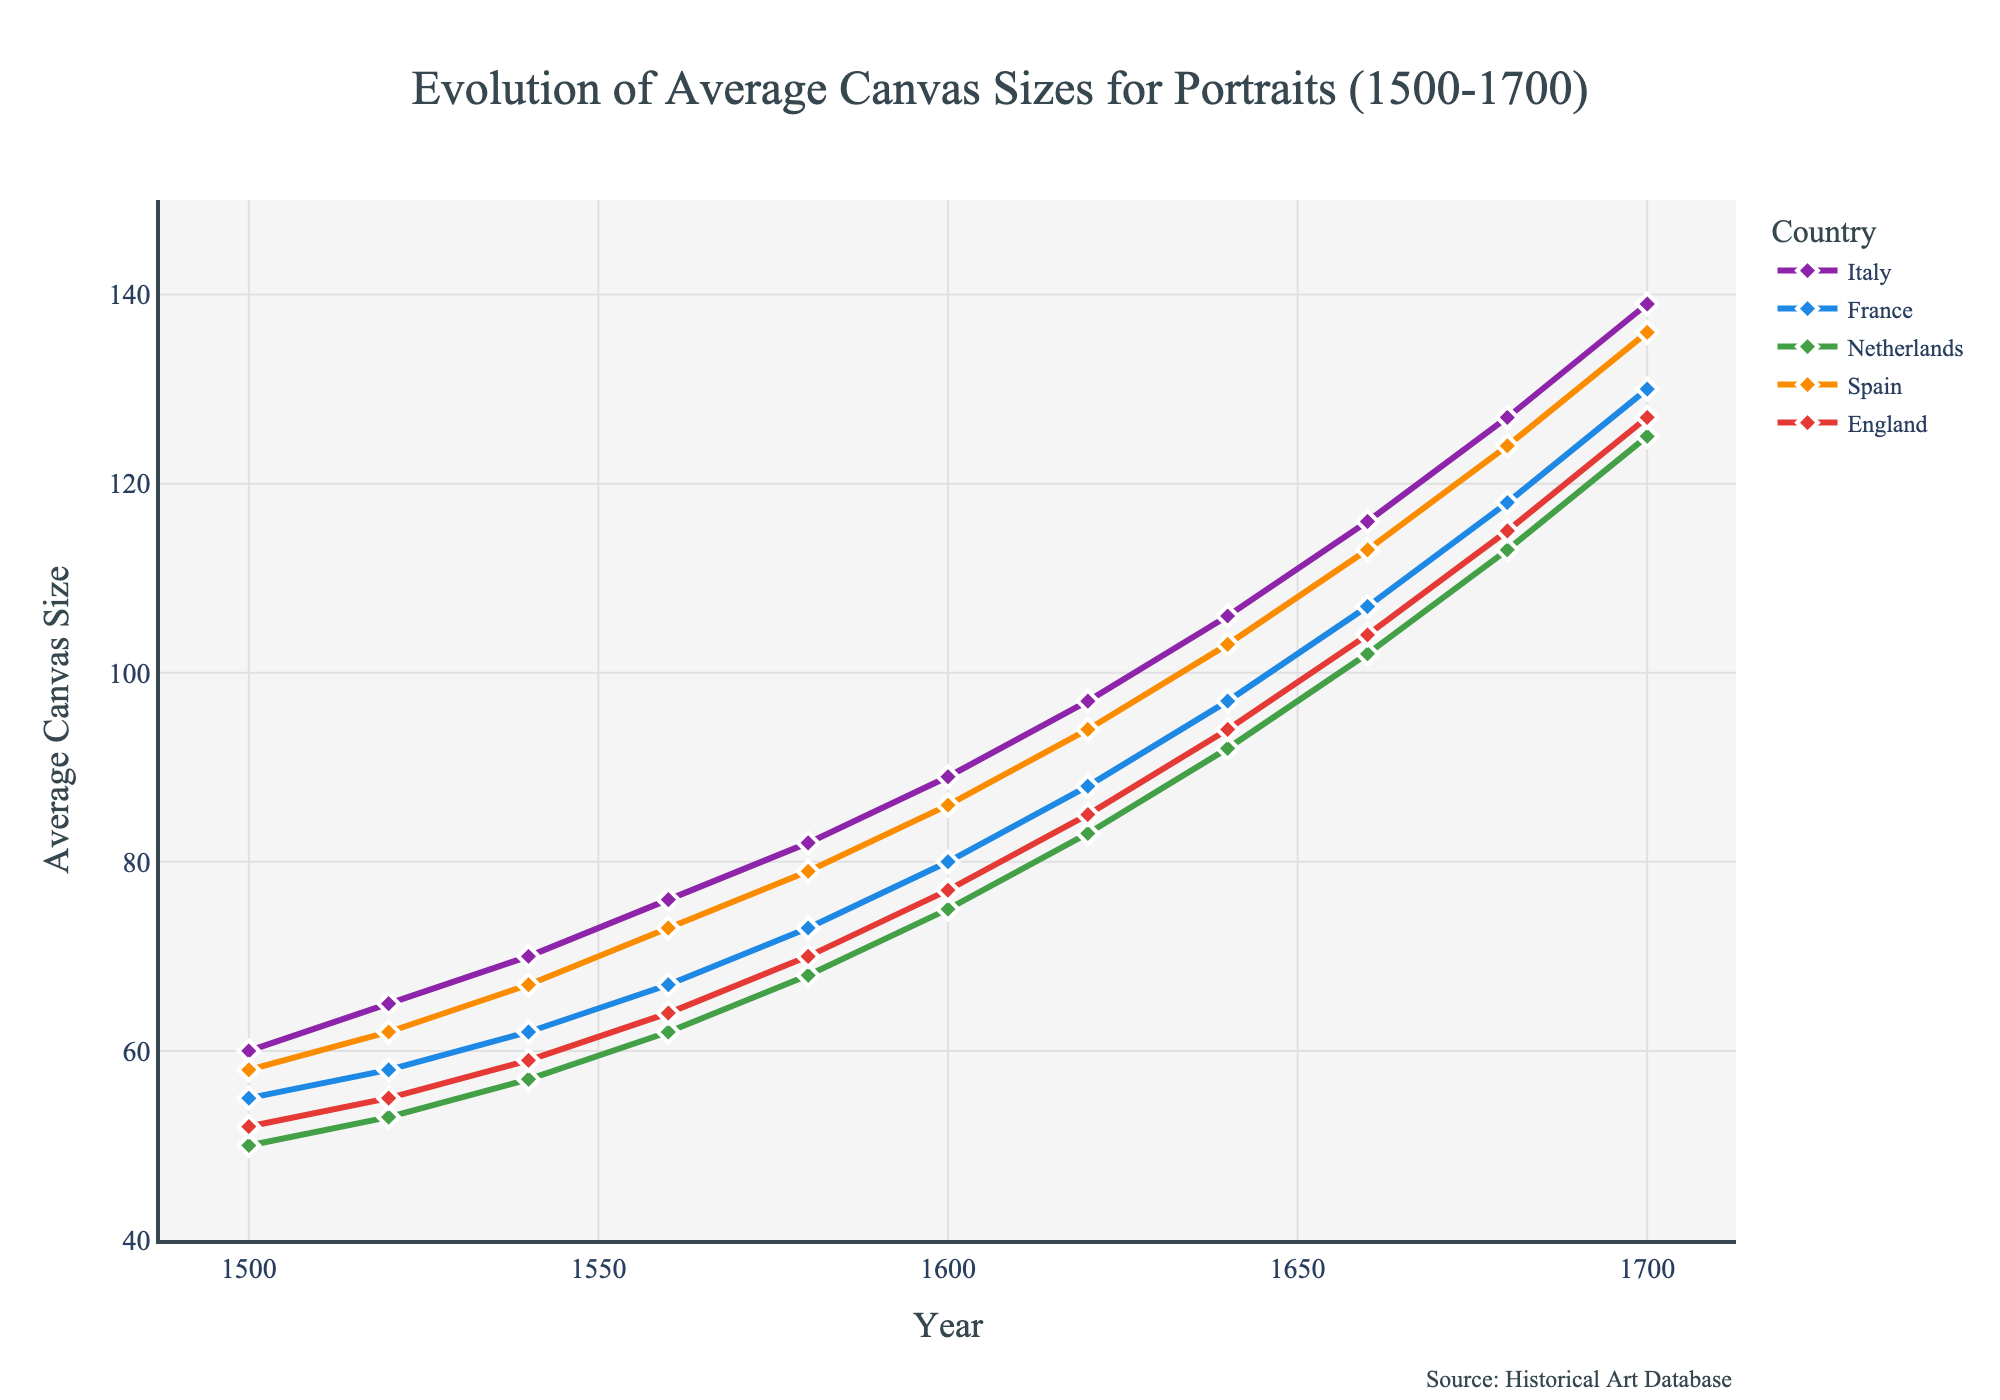What's the overall trend in the average canvas size for portraits in Italy from 1500 to 1700? The overall trend in Italy shows a steady increase in the average canvas size from 60 to 139 units.
Answer: Steady increase Between the Netherlands and England, which country's average canvas size increased more from 1500 to 1700? In 1500, the Netherlands started at 50 units and increased to 125 units by 1700, resulting in a 75-unit increase. England started at 52 units and increased to 127 units by 1700, resulting in a 75-unit increase. Therefore, both countries had the same increase of 75 units.
Answer: Both had the same increase Which country had the highest average canvas size in 1680? In 1680, Italy had the highest average canvas size at 127 units, followed by France at 118 units, the Netherlands at 113 units, Spain at 124 units, and England at 115 units.
Answer: Italy How many countries had a lower average canvas size than France in 1600? In 1600, France had an average canvas size of 80 units. The Netherlands, Spain, and England had lower average canvas sizes at 75, 86, and 77 units, respectively, resulting in 3 countries with lower canvas sizes.
Answer: 3 What is the average increase in canvas size for Spain from each time period (20-year gaps) between 1500 and 1700? The canvas sizes for Spain at each 20-year interval between 1500 and 1700 are 58, 62, 67, 73, 79, 86, 94, 103, 113, 124, 136 units. The total increase over 10 intervals is 136 - 58 = 78 units. The average increase per period is 78 / 10 = 7.8 units.
Answer: 7.8 units per period Which country showed the least increase in average canvas size from 1500 to 1540? From 1500 to 1540, Italy increased from 60 to 70 units (10 units), France increased from 55 to 62 units (7 units), the Netherlands increased from 50 to 57 units (7 units), Spain increased from 58 to 67 units (9 units), and England increased from 52 to 59 units (7 units). The smallest increase was shown by France, the Netherlands, and England, each with a 7-unit increase.
Answer: France, Netherlands, and England Did the average canvas size for any country remain constant between any 20-year gap? If yes, which country and between which years? By examining the data, we see that in each 20-year interval, there are changes in the average canvas sizes for all countries. Therefore, no country's average canvas size remained constant.
Answer: No Comparing Italy and Spain, which country had more significant fluctuations in average canvas size between 1500 and 1700? Calculating the differences between each 20-year interval for Italy (5, 5, 6, 6, 7, 8, 9, 10, 11, 12) and Spain (4, 5, 6, 6, 7, 8, 9, 10, 11, 12), both countries experienced the same magnitude of fluctuations.
Answer: Both had similar fluctuations 